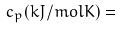Convert formula to latex. <formula><loc_0><loc_0><loc_500><loc_500>c _ { p } ( k J / m o l K ) =</formula> 